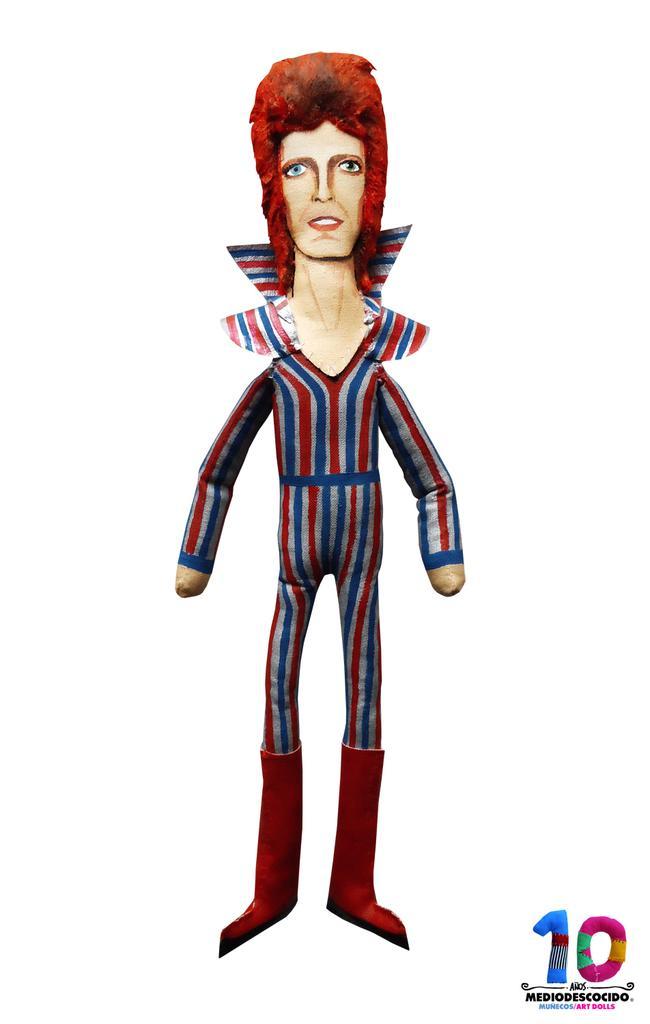Can you describe this image briefly? In this picture there is a cartoon poster of the man wearing red and blue color dress. On the bottom there is a small quote and number written on it. Behind there is a white background. 